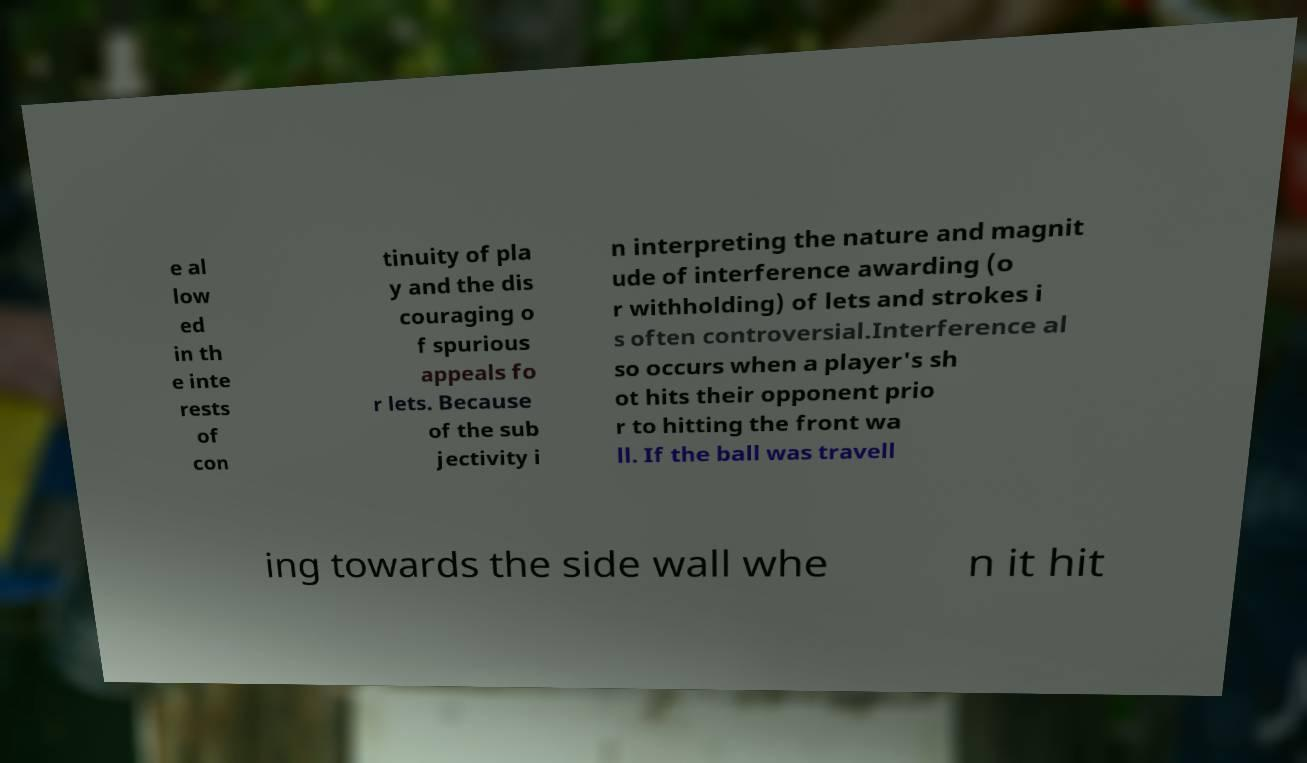Please identify and transcribe the text found in this image. e al low ed in th e inte rests of con tinuity of pla y and the dis couraging o f spurious appeals fo r lets. Because of the sub jectivity i n interpreting the nature and magnit ude of interference awarding (o r withholding) of lets and strokes i s often controversial.Interference al so occurs when a player's sh ot hits their opponent prio r to hitting the front wa ll. If the ball was travell ing towards the side wall whe n it hit 